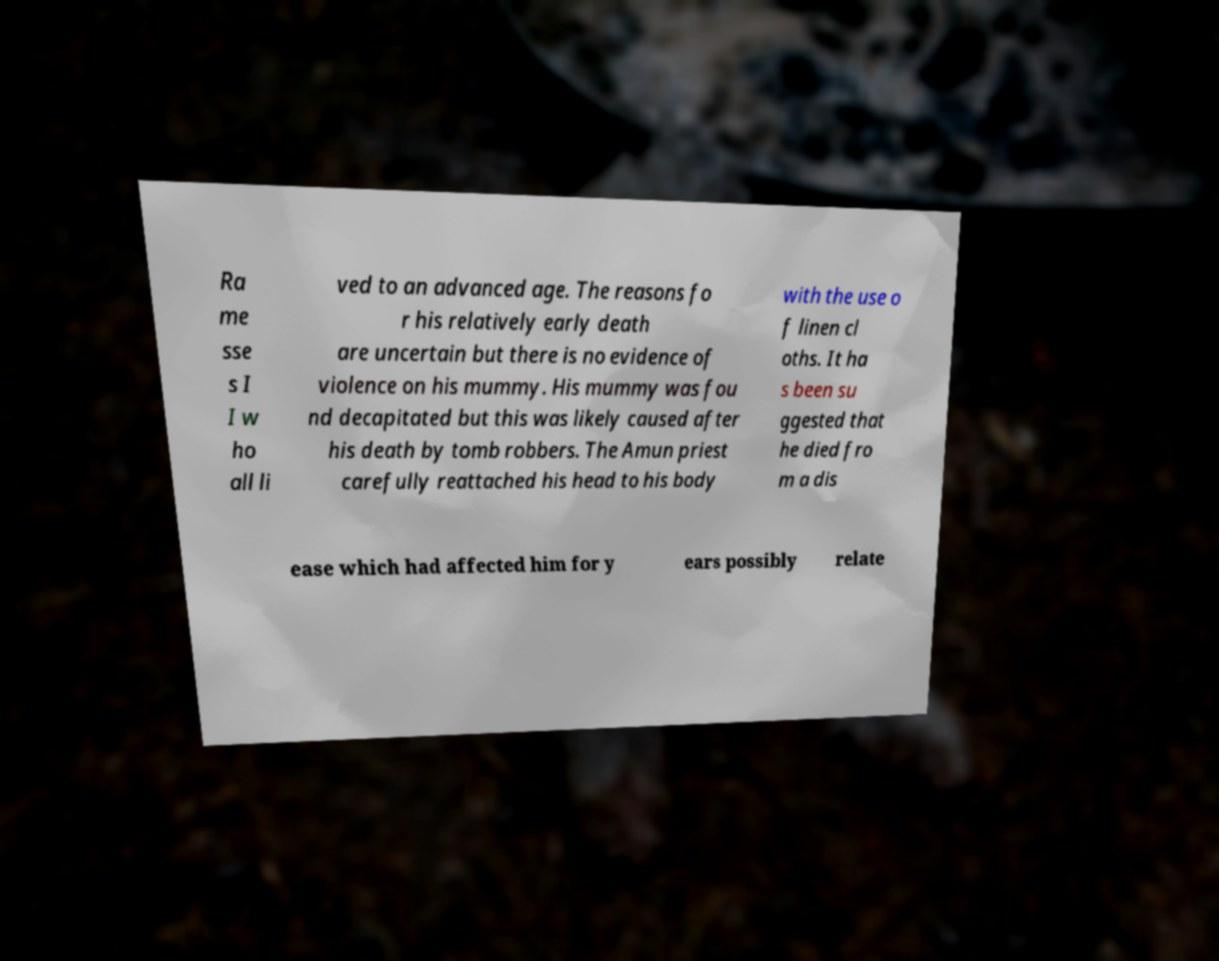I need the written content from this picture converted into text. Can you do that? Ra me sse s I I w ho all li ved to an advanced age. The reasons fo r his relatively early death are uncertain but there is no evidence of violence on his mummy. His mummy was fou nd decapitated but this was likely caused after his death by tomb robbers. The Amun priest carefully reattached his head to his body with the use o f linen cl oths. It ha s been su ggested that he died fro m a dis ease which had affected him for y ears possibly relate 